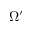<formula> <loc_0><loc_0><loc_500><loc_500>\Omega ^ { \prime }</formula> 